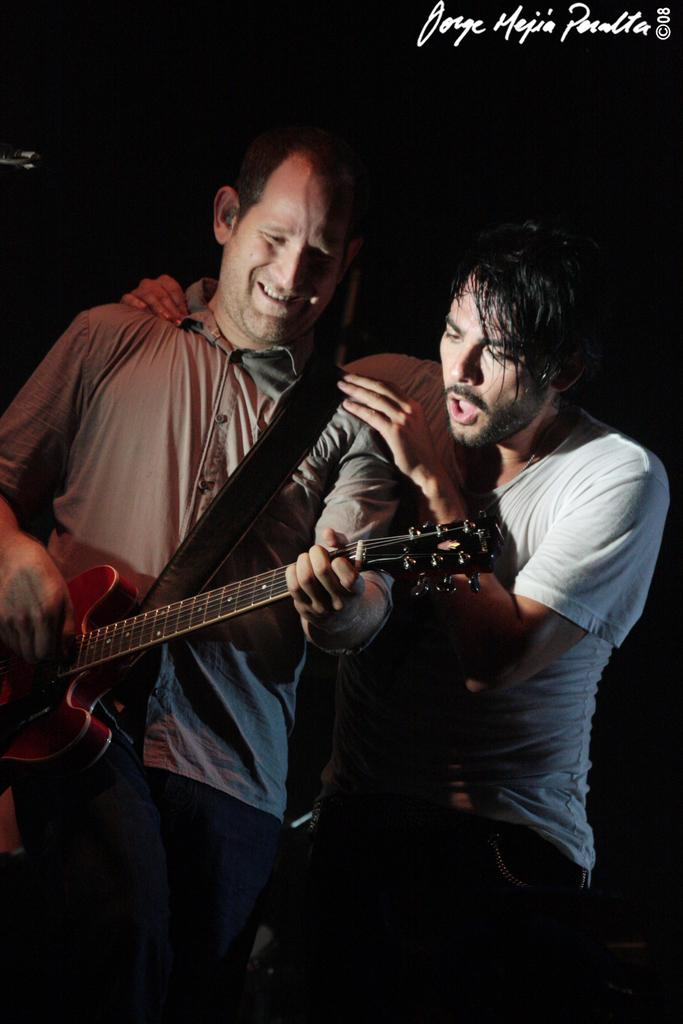How many people are in the image? There are two people in the image. What are the two people doing in the image? The two people are standing and playing musical instruments. What type of camera is being used by the person in the image? There is no camera present in the image; the two people are playing musical instruments. How many people are needed to sort the musical instruments in the image? There is no sorting activity taking place in the image, as the two people are playing the instruments. 